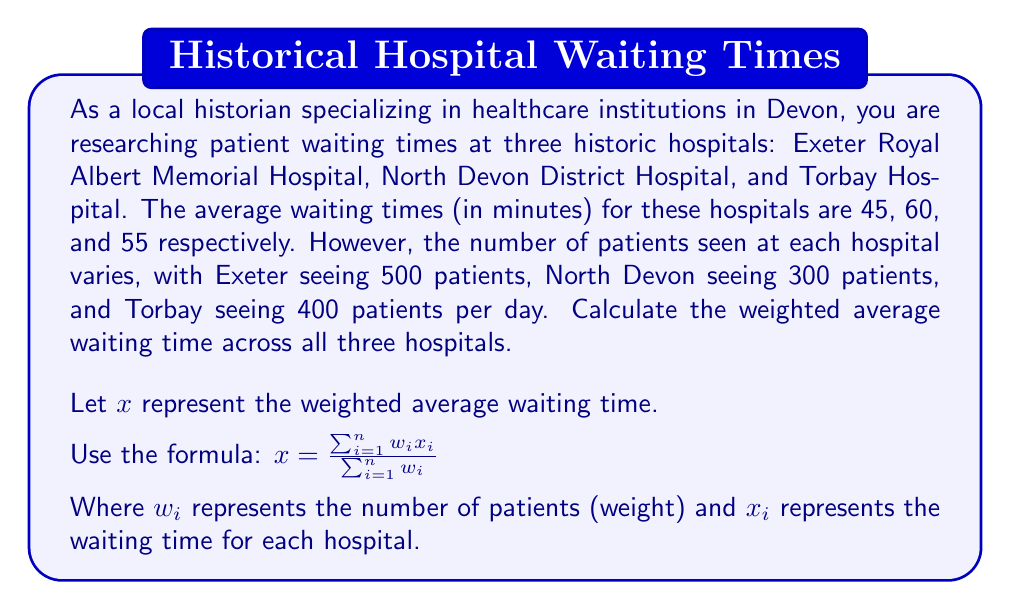Could you help me with this problem? To solve this problem, we need to use the weighted average formula:

$$x = \frac{\sum_{i=1}^{n} w_i x_i}{\sum_{i=1}^{n} w_i}$$

Where:
$x$ is the weighted average waiting time
$w_i$ is the number of patients for each hospital (weight)
$x_i$ is the waiting time for each hospital

Let's break down the calculation step by step:

1. Identify the values for each hospital:
   Exeter: $w_1 = 500$, $x_1 = 45$
   North Devon: $w_2 = 300$, $x_2 = 60$
   Torbay: $w_3 = 400$, $x_3 = 55$

2. Calculate the numerator $\sum_{i=1}^{n} w_i x_i$:
   $$(500 \times 45) + (300 \times 60) + (400 \times 55) = 22500 + 18000 + 22000 = 62500$$

3. Calculate the denominator $\sum_{i=1}^{n} w_i$:
   $$500 + 300 + 400 = 1200$$

4. Apply the weighted average formula:
   $$x = \frac{62500}{1200} = 52.0833...$$

5. Round the result to two decimal places:
   $$x \approx 52.08$$
Answer: The weighted average waiting time across all three historic hospitals in Devon is approximately 52.08 minutes. 